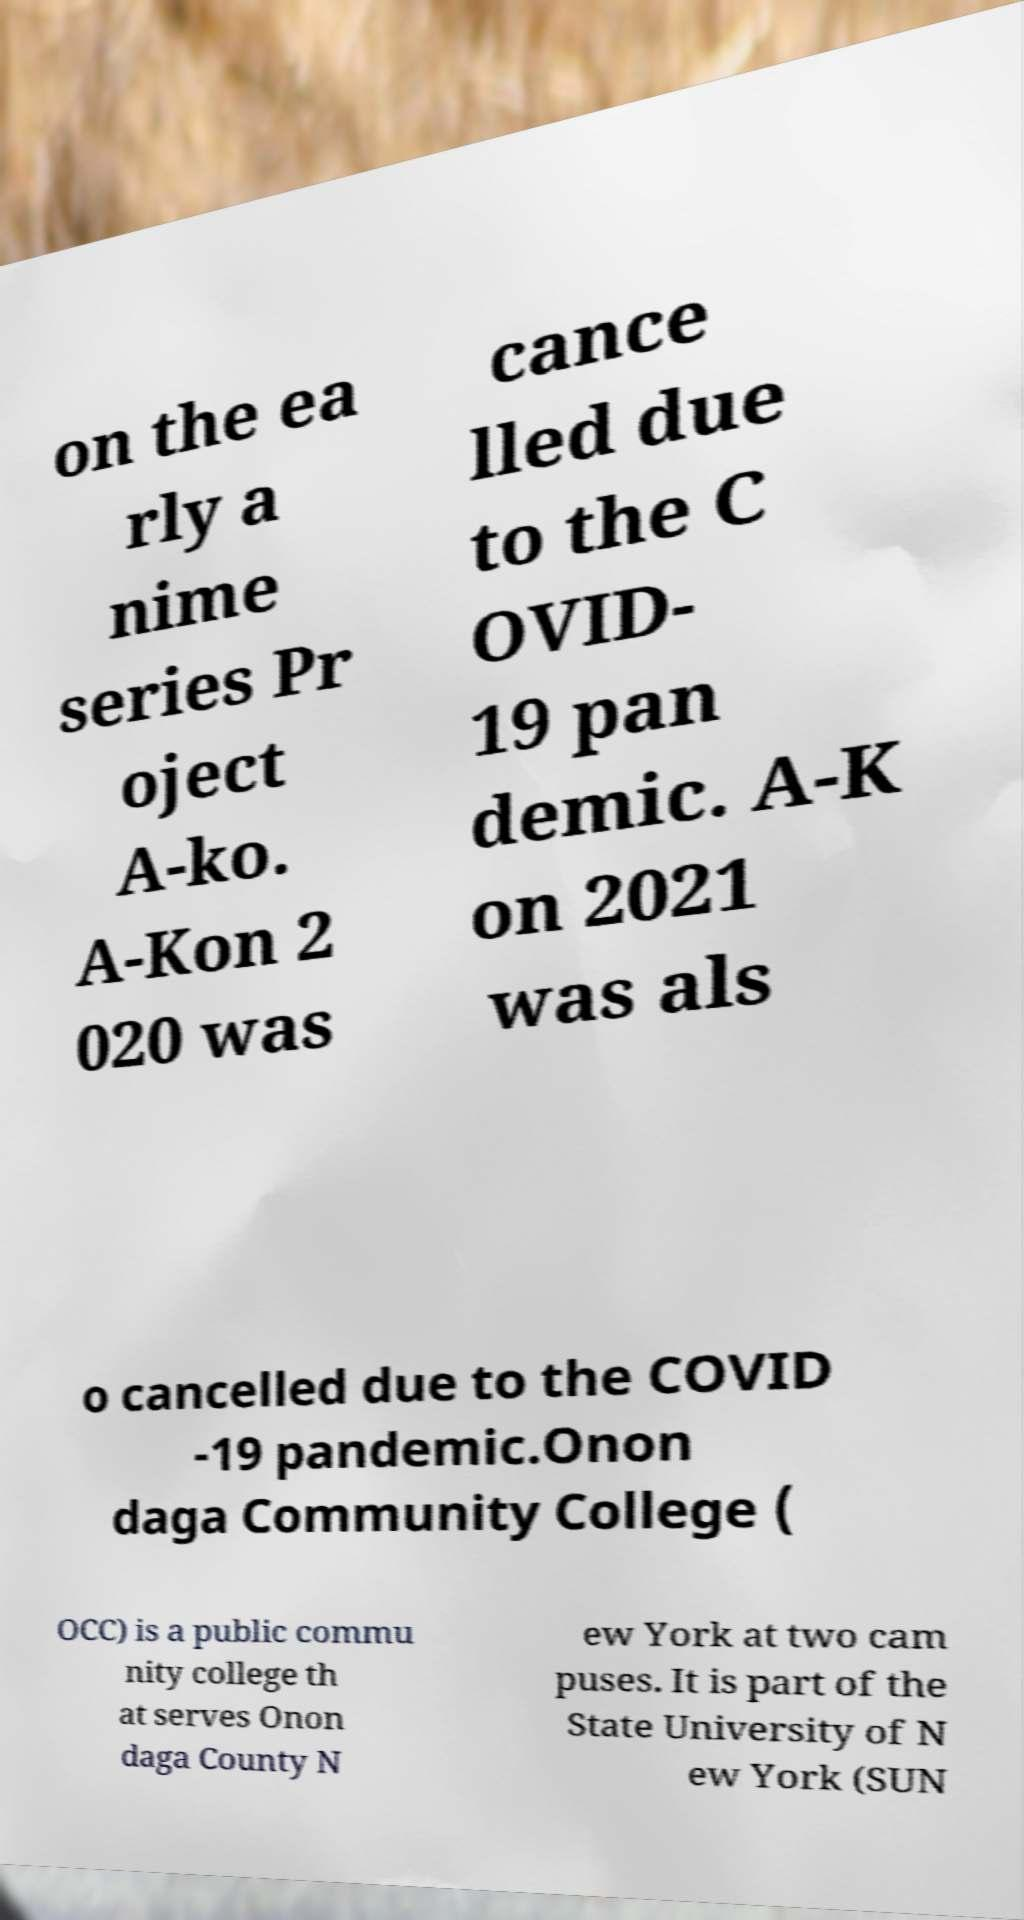I need the written content from this picture converted into text. Can you do that? on the ea rly a nime series Pr oject A-ko. A-Kon 2 020 was cance lled due to the C OVID- 19 pan demic. A-K on 2021 was als o cancelled due to the COVID -19 pandemic.Onon daga Community College ( OCC) is a public commu nity college th at serves Onon daga County N ew York at two cam puses. It is part of the State University of N ew York (SUN 